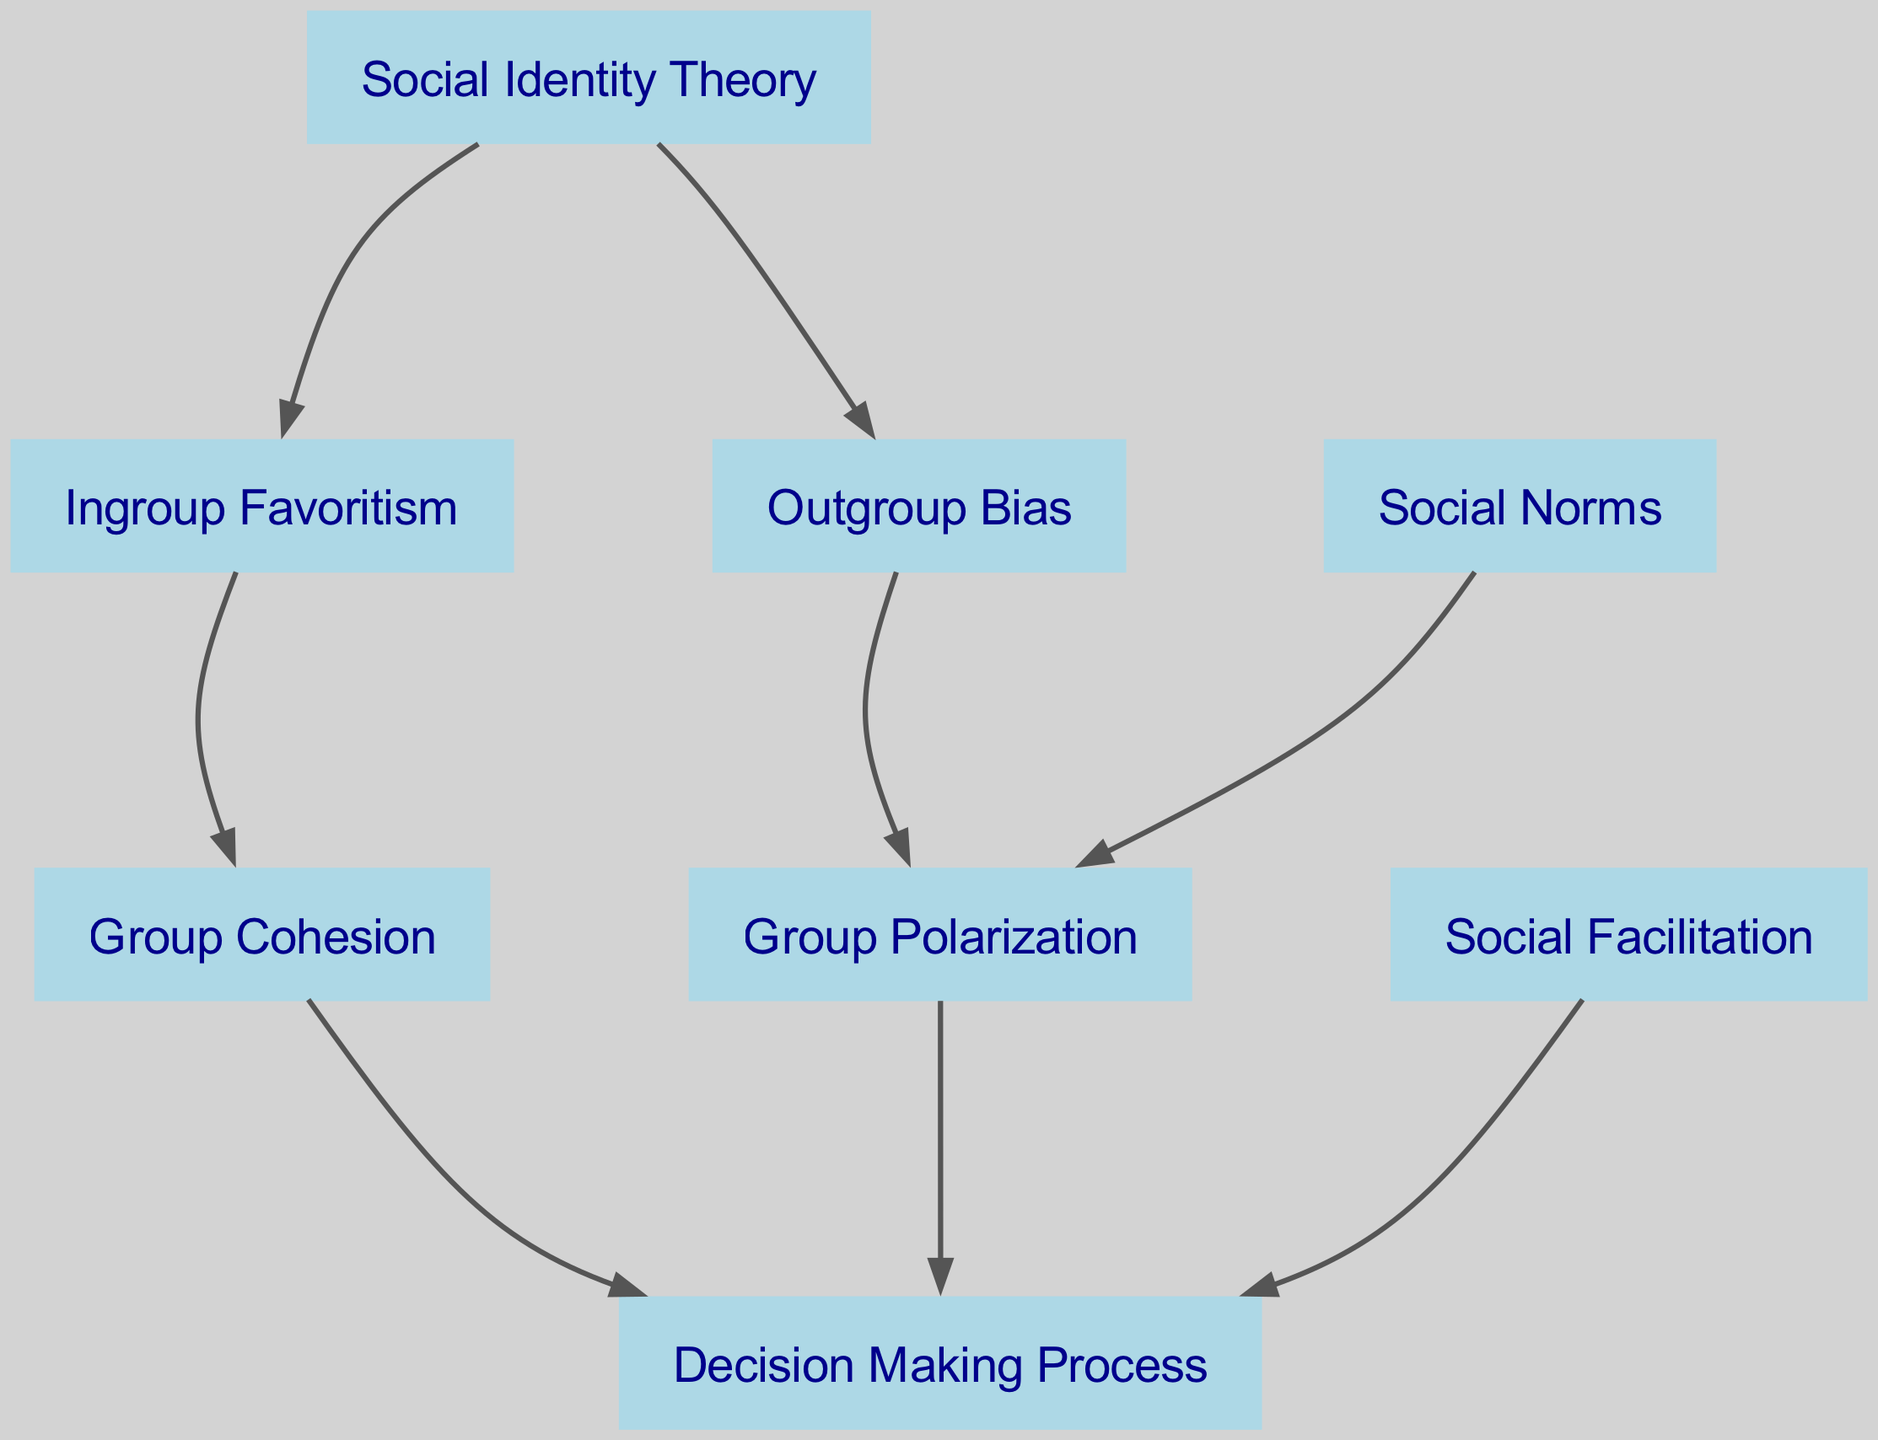What are the total number of nodes in the diagram? The diagram's data contains a list labeled "nodes" that includes eight unique entries. These entries correspond to the various concepts, indicating that the total number of nodes in the diagram is eight.
Answer: 8 What is the relationship between Social Identity Theory and Outgroup Bias? The edge from "Social Identity Theory" to "Outgroup Bias" indicates a direct influence or relationship, signifying that Social Identity Theory contributes to Outgroup Bias.
Answer: Influence Which nodes have a direct connection to the Decision Making Process? By examining the edges connected to the "Decision Making Process" node, we see it is directly linked to "Group Cohesion", "Group Polarization", and "Social Facilitation". Therefore, these three nodes directly connect to the Decision Making Process.
Answer: Group Cohesion, Group Polarization, Social Facilitation How many edges are present in the diagram? The diagram's data includes a list labeled "edges" with a total of eight entries, showing the relationships between the nodes. Therefore, the number of edges in the diagram is eight.
Answer: 8 What effect does Ingroup Favoritism have on Group Cohesion? The directed edge from "Ingroup Favoritism" to "Group Cohesion" indicates that Ingroup Favoritism enhances or strengthens Group Cohesion, illustrating the positive impact of belonging to a favored group on group unity.
Answer: Enhances Which nodes influence Group Polarization? The connections leading to "Group Polarization" include edges from both "Outgroup Bias" and "Social Norms" as well as the "Social Identity Theory" indirectly influences it. Therefore, multiple nodes contribute to Group Polarization.
Answer: Outgroup Bias, Social Norms Does Social Facilitation have an impact on Decision Making Process? The edge shows a direct connection from "Social Facilitation" to "Decision Making Process", indicating that Social Facilitation does indeed impact the Decision Making Process.
Answer: Yes Name one node that is influenced by Outgroup Bias. The edge from "Outgroup Bias" points directly to "Group Polarization", indicating that Group Polarization is influenced by Outgroup Bias.
Answer: Group Polarization Which node is connected to both Group Cohesion and Group Polarization? Examining the edges, "Decision Making Process" is the node influenced by both "Group Cohesion" and "Group Polarization". Therefore, it acts as a common consequence of these two aspects.
Answer: Decision Making Process 